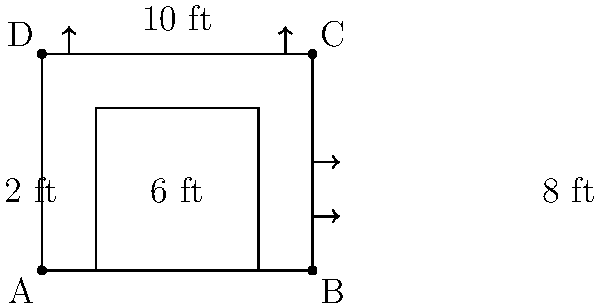For your rustic barn wedding, you want to design a wooden arch that will frame the entrance to the reception area. The arch should be 10 feet wide and 8 feet tall, with a 2-foot border on each side and the top. What should be the dimensions of the inner opening of the arch? To find the dimensions of the inner opening of the arch, we need to follow these steps:

1. Understand the given dimensions:
   - Total width of the arch = 10 feet
   - Total height of the arch = 8 feet
   - Border width on each side and top = 2 feet

2. Calculate the width of the inner opening:
   - Inner width = Total width - (2 × Border width)
   - Inner width = 10 feet - (2 × 2 feet)
   - Inner width = 10 feet - 4 feet = 6 feet

3. Calculate the height of the inner opening:
   - Inner height = Total height - Border width at the top
   - Inner height = 8 feet - 2 feet = 6 feet

Therefore, the dimensions of the inner opening of the arch are 6 feet wide and 6 feet tall.
Answer: 6 feet × 6 feet 